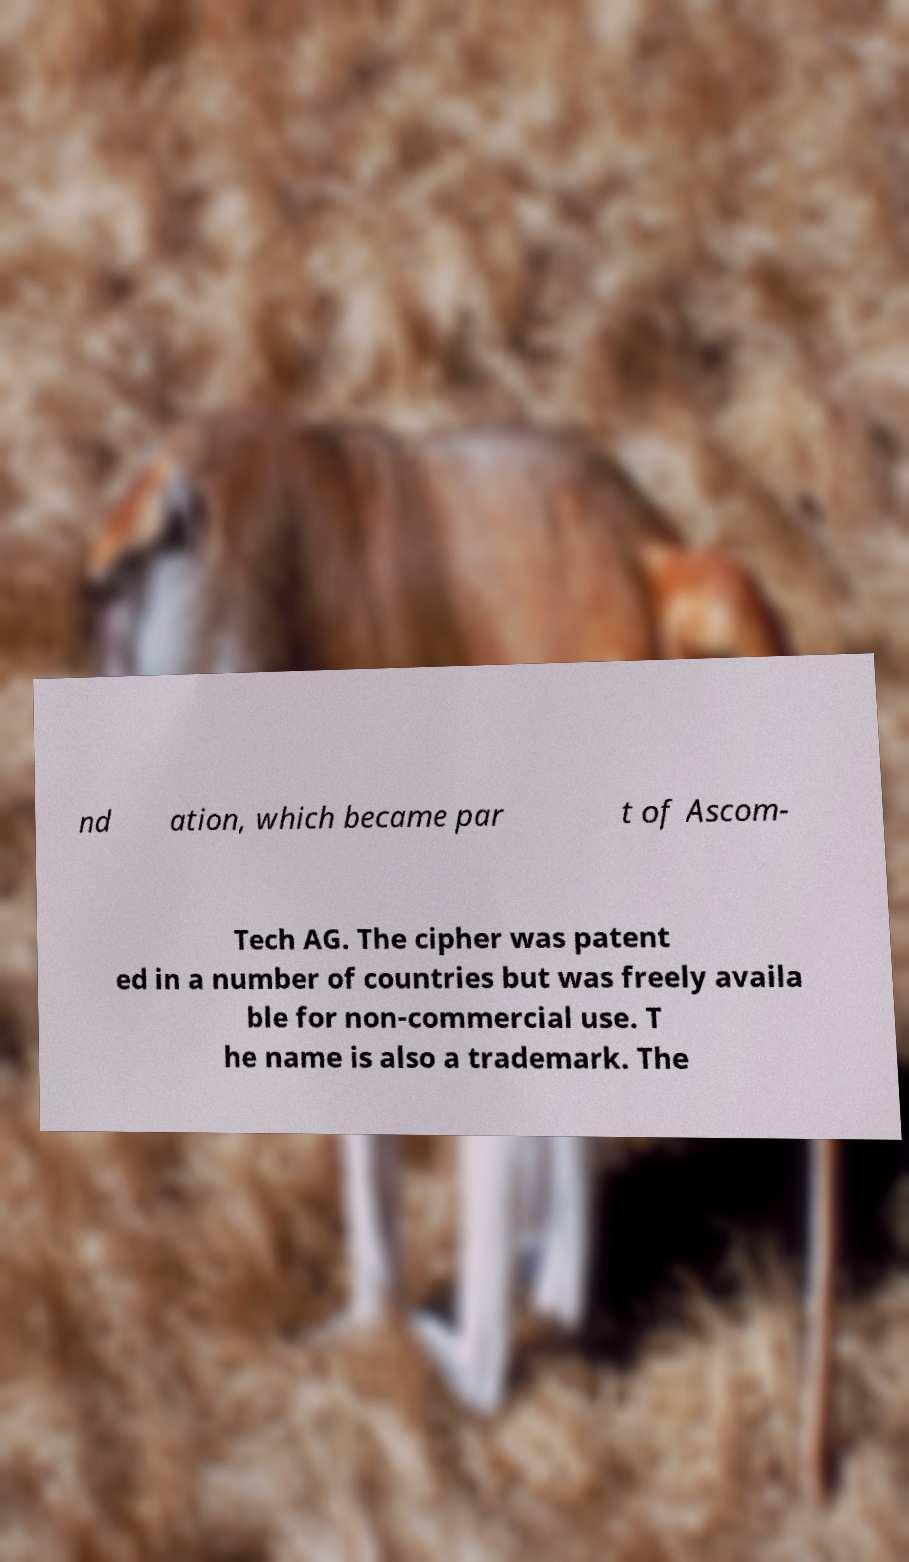Could you extract and type out the text from this image? nd ation, which became par t of Ascom- Tech AG. The cipher was patent ed in a number of countries but was freely availa ble for non-commercial use. T he name is also a trademark. The 